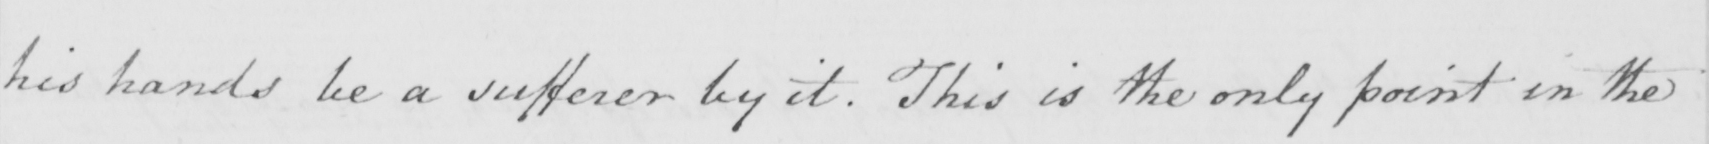What does this handwritten line say? his hands be a sufferer by it . This is the only point in the 